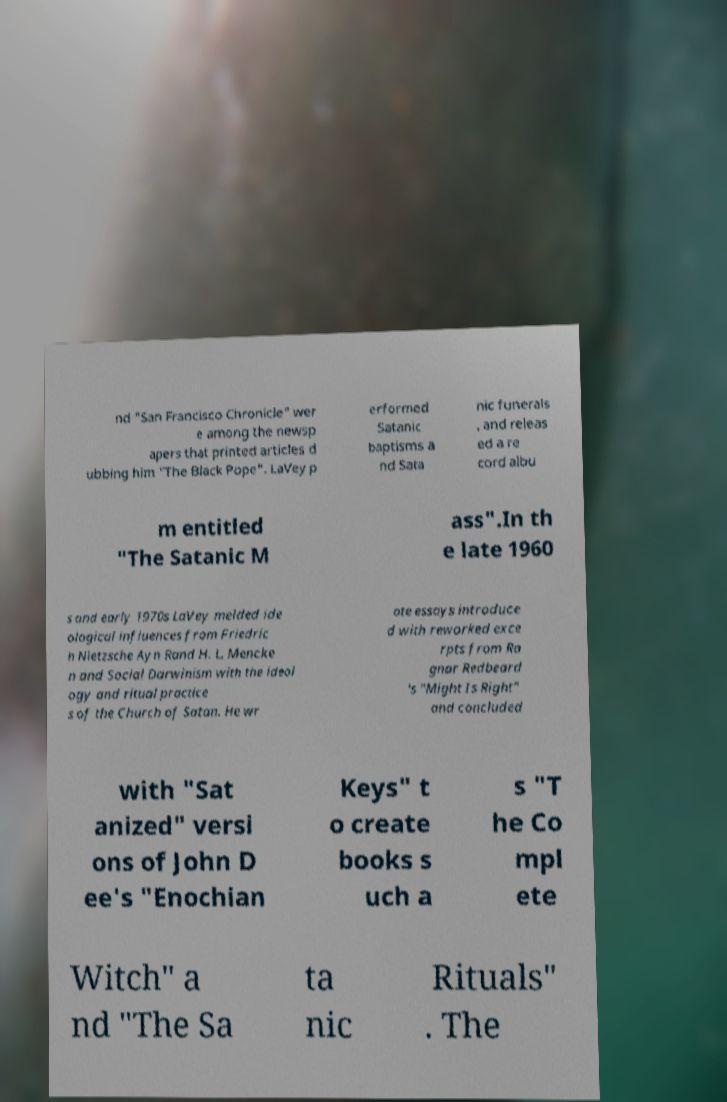Could you assist in decoding the text presented in this image and type it out clearly? nd "San Francisco Chronicle" wer e among the newsp apers that printed articles d ubbing him "The Black Pope". LaVey p erformed Satanic baptisms a nd Sata nic funerals , and releas ed a re cord albu m entitled "The Satanic M ass".In th e late 1960 s and early 1970s LaVey melded ide ological influences from Friedric h Nietzsche Ayn Rand H. L. Mencke n and Social Darwinism with the ideol ogy and ritual practice s of the Church of Satan. He wr ote essays introduce d with reworked exce rpts from Ra gnar Redbeard 's "Might Is Right" and concluded with "Sat anized" versi ons of John D ee's "Enochian Keys" t o create books s uch a s "T he Co mpl ete Witch" a nd "The Sa ta nic Rituals" . The 